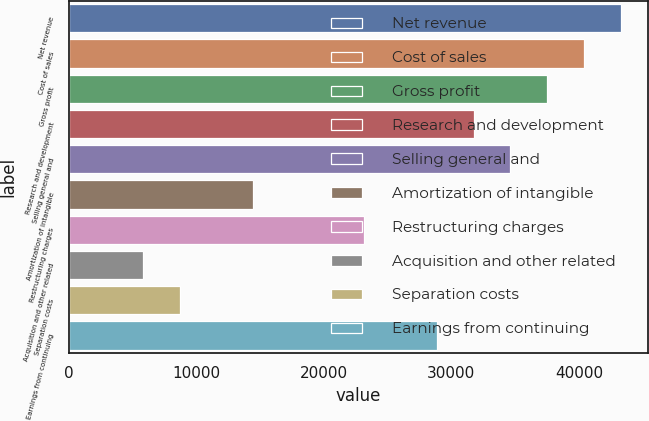Convert chart to OTSL. <chart><loc_0><loc_0><loc_500><loc_500><bar_chart><fcel>Net revenue<fcel>Cost of sales<fcel>Gross profit<fcel>Research and development<fcel>Selling general and<fcel>Amortization of intangible<fcel>Restructuring charges<fcel>Acquisition and other related<fcel>Separation costs<fcel>Earnings from continuing<nl><fcel>43260.5<fcel>40382.6<fcel>37504.7<fcel>31748.9<fcel>34626.8<fcel>14481.5<fcel>23115.2<fcel>5847.8<fcel>8725.7<fcel>28871<nl></chart> 